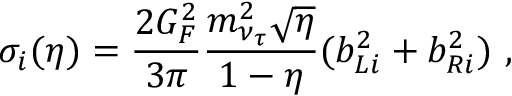Convert formula to latex. <formula><loc_0><loc_0><loc_500><loc_500>\sigma _ { i } ( \eta ) = \frac { 2 G _ { F } ^ { 2 } } { 3 \pi } \frac { m _ { \nu _ { \tau } } ^ { 2 } \sqrt { \eta } } { 1 - \eta } ( b _ { L i } ^ { 2 } + b _ { R i } ^ { 2 } ) ,</formula> 